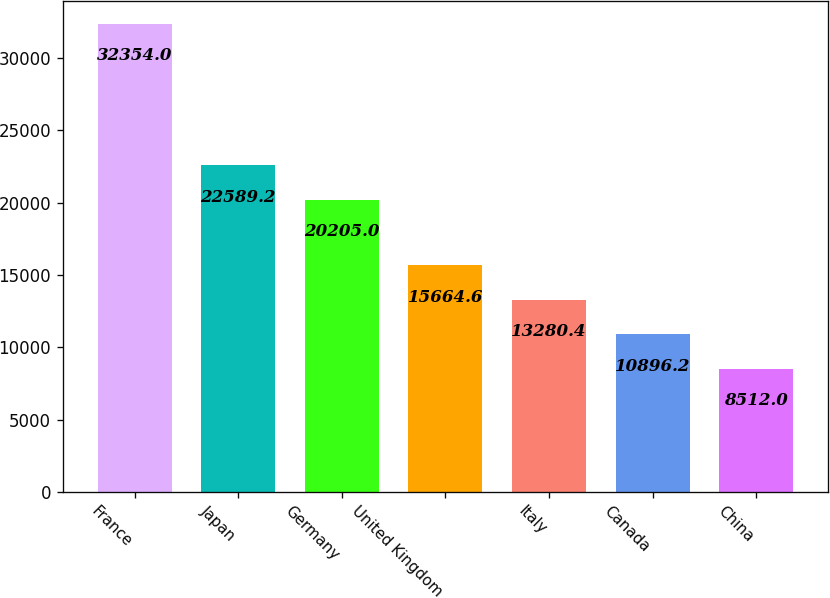Convert chart to OTSL. <chart><loc_0><loc_0><loc_500><loc_500><bar_chart><fcel>France<fcel>Japan<fcel>Germany<fcel>United Kingdom<fcel>Italy<fcel>Canada<fcel>China<nl><fcel>32354<fcel>22589.2<fcel>20205<fcel>15664.6<fcel>13280.4<fcel>10896.2<fcel>8512<nl></chart> 